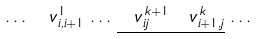<formula> <loc_0><loc_0><loc_500><loc_500>\dots \, \ v _ { i , i + 1 } ^ { 1 } \, \dots \, \underline { \ v _ { i j } ^ { \, k + 1 } \, \ v _ { i + 1 , j } ^ { \, k } } \, \dots</formula> 